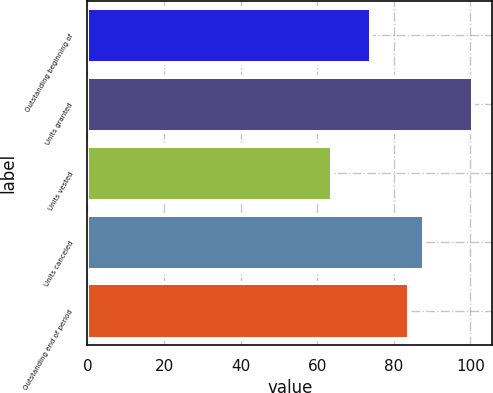Convert chart. <chart><loc_0><loc_0><loc_500><loc_500><bar_chart><fcel>Outstanding beginning of<fcel>Units granted<fcel>Units vested<fcel>Units canceled<fcel>Outstanding end of period<nl><fcel>74.04<fcel>100.72<fcel>63.91<fcel>87.79<fcel>84.11<nl></chart> 